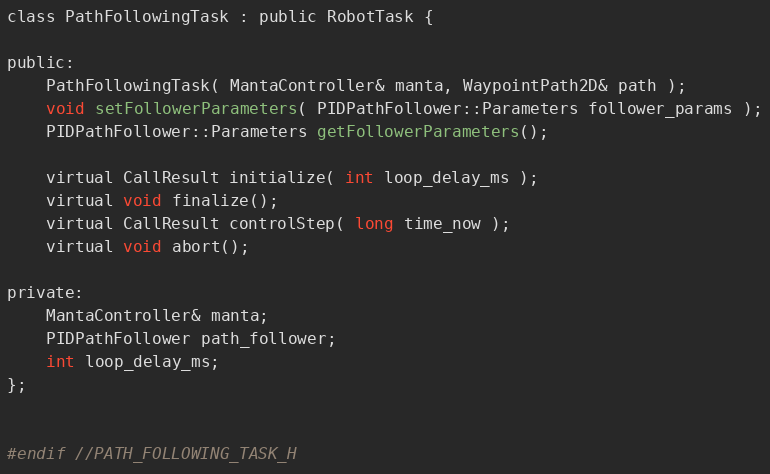Convert code to text. <code><loc_0><loc_0><loc_500><loc_500><_C_>

class PathFollowingTask : public RobotTask {

public:
    PathFollowingTask( MantaController& manta, WaypointPath2D& path );
    void setFollowerParameters( PIDPathFollower::Parameters follower_params );
    PIDPathFollower::Parameters getFollowerParameters();

    virtual CallResult initialize( int loop_delay_ms );
    virtual void finalize();
    virtual CallResult controlStep( long time_now );
    virtual void abort();

private:
    MantaController& manta;
    PIDPathFollower path_follower;
    int loop_delay_ms;
};


#endif //PATH_FOLLOWING_TASK_H
</code> 